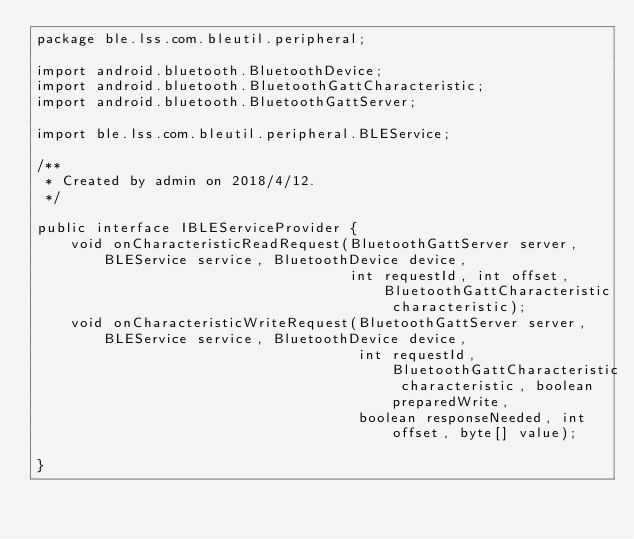<code> <loc_0><loc_0><loc_500><loc_500><_Java_>package ble.lss.com.bleutil.peripheral;

import android.bluetooth.BluetoothDevice;
import android.bluetooth.BluetoothGattCharacteristic;
import android.bluetooth.BluetoothGattServer;

import ble.lss.com.bleutil.peripheral.BLEService;

/**
 * Created by admin on 2018/4/12.
 */

public interface IBLEServiceProvider {
    void onCharacteristicReadRequest(BluetoothGattServer server, BLEService service, BluetoothDevice device,
                                     int requestId, int offset, BluetoothGattCharacteristic characteristic);
    void onCharacteristicWriteRequest(BluetoothGattServer server,BLEService service, BluetoothDevice device,
                                      int requestId, BluetoothGattCharacteristic characteristic, boolean preparedWrite,
                                      boolean responseNeeded, int offset, byte[] value);

}
</code> 